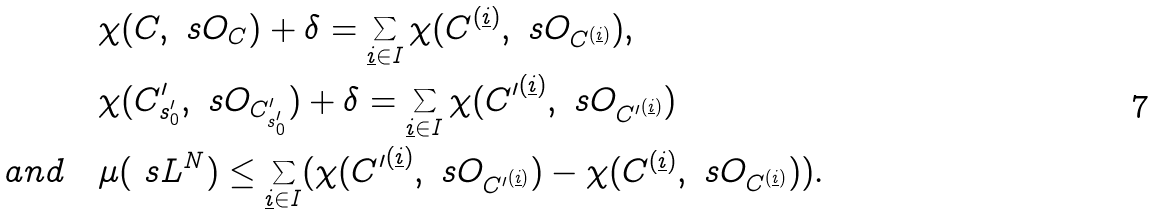<formula> <loc_0><loc_0><loc_500><loc_500>& \chi ( C , \ s O _ { C } ) + \delta = \sum _ { \underline { i } \in I } \chi ( { C } ^ { ( \underline { i } ) } , \ s O _ { { C } ^ { ( \underline { i } ) } } ) , \\ & \chi ( C ^ { \prime } _ { s ^ { \prime } _ { 0 } } , \ s O _ { C ^ { \prime } _ { s ^ { \prime } _ { 0 } } } ) + \delta = \sum _ { \underline { i } \in I } \chi ( { C ^ { \prime } } ^ { ( \underline { i } ) } , \ s O _ { { C ^ { \prime } } ^ { ( \underline { i } ) } } ) \\ a n d \quad & \mu ( \ s L ^ { N } ) \leq \sum _ { \underline { i } \in I } ( \chi ( { C ^ { \prime } } ^ { ( \underline { i } ) } , \ s O _ { { C ^ { \prime } } ^ { ( \underline { i } ) } } ) - \chi ( { C } ^ { ( \underline { i } ) } , \ s O _ { { C } ^ { ( \underline { i } ) } } ) ) .</formula> 